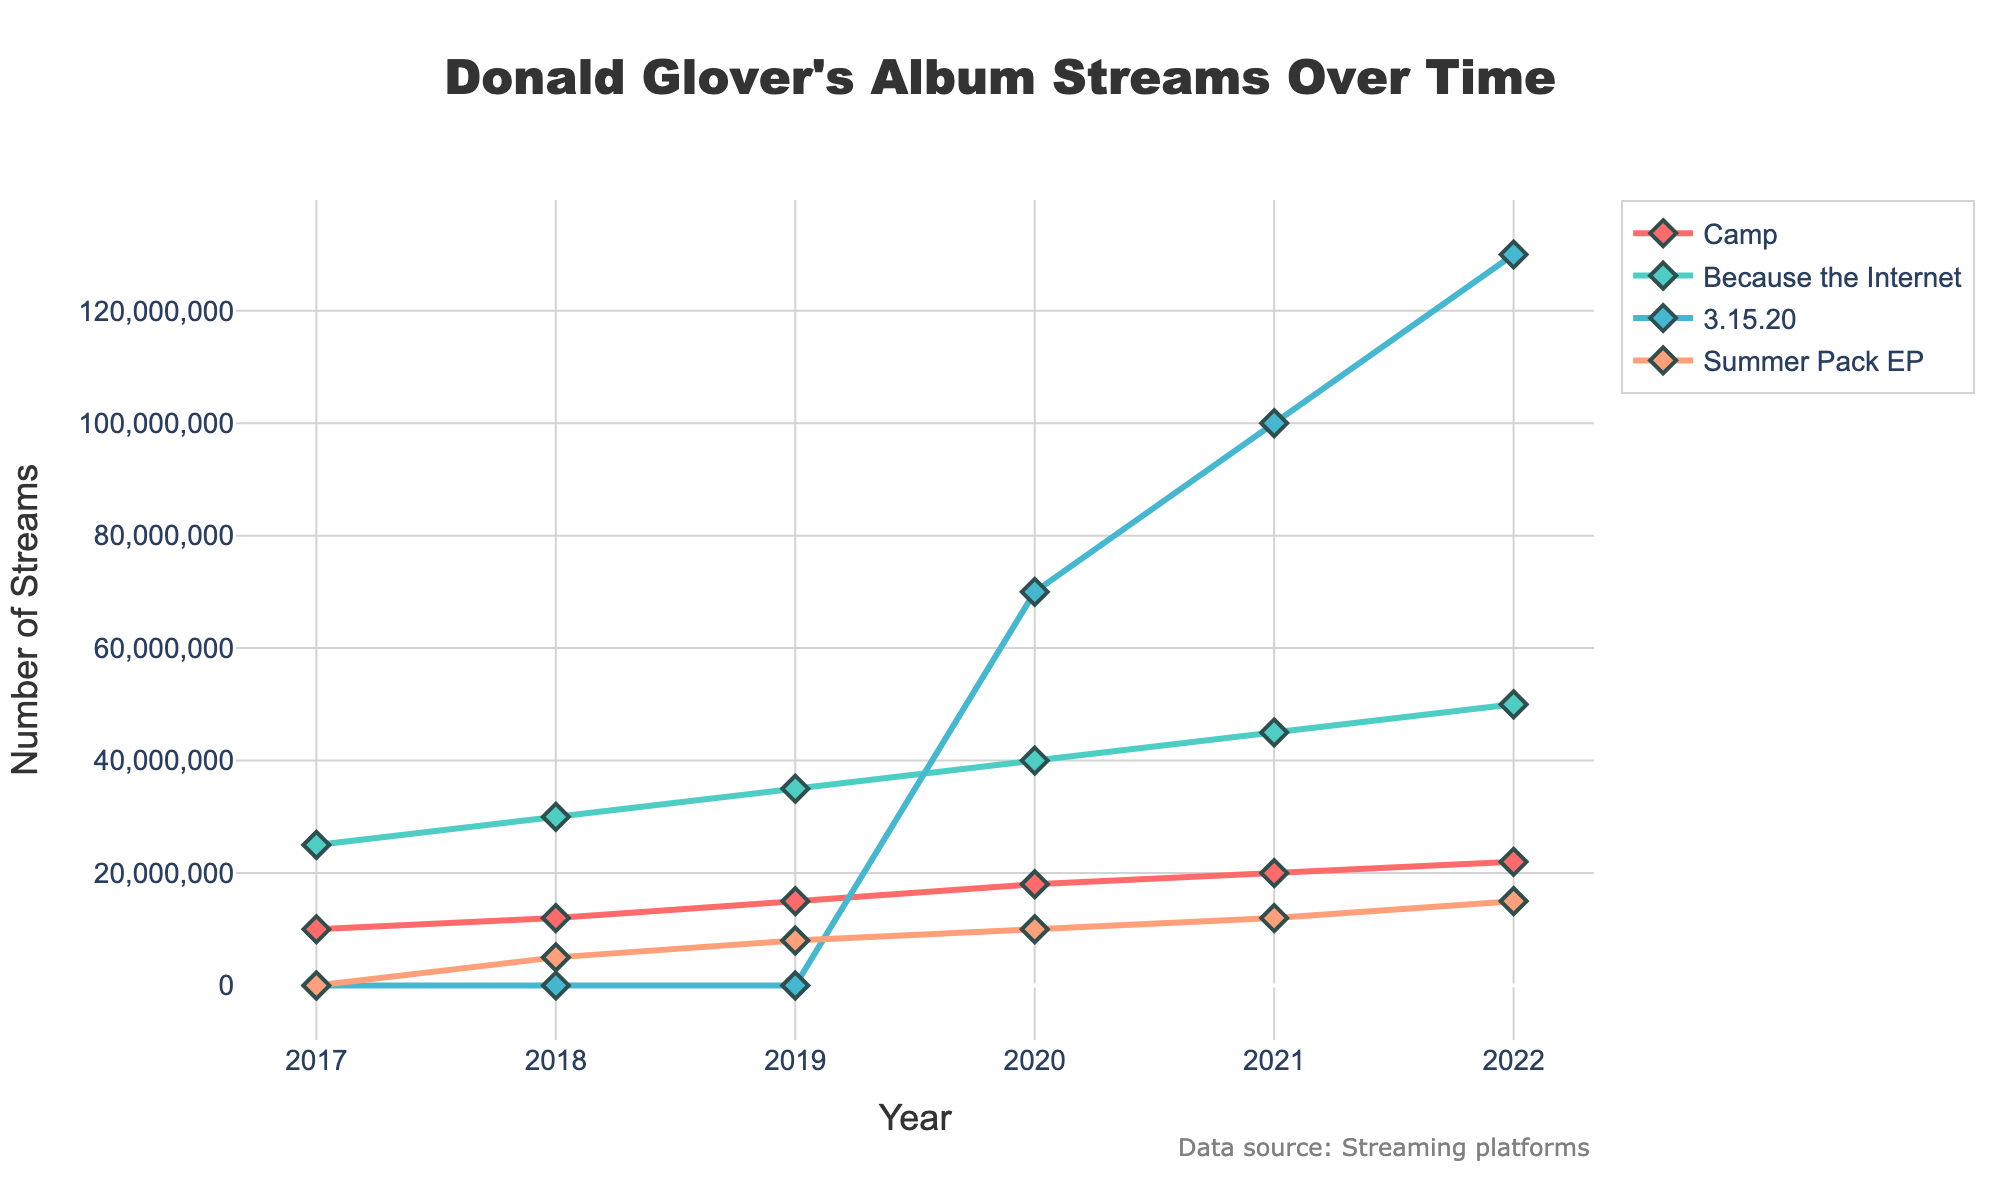What is the total number of streams for the album "3.15.20" from 2020 to 2022? Add the number of streams for "3.15.20" in 2020, 2021, and 2022: 70,000,000 + 100,000,000 + 130,000,000 = 300,000,000
Answer: 300,000,000 In 2020, which album had more streams: "Camp" or "Summer Pack EP"? Compare the number of streams for "Camp" and "Summer Pack EP" in 2020: "Camp" had 18,000,000 streams and "Summer Pack EP" had 10,000,000 streams. 18,000,000 > 10,000,000
Answer: "Camp" Which album showed the most significant increase in streams between 2019 and 2020? Compare the increase in streams for 2019 and 2020 for each album and find the greatest difference: "Camp" increased by 3,000,000, "Because the Internet" increased by 5,000,000, "3.15.20" was newly released with 70,000,000, and "Summer Pack EP" increased by 2,000,000. The largest increase is 70,000,000 for "3.15.20"
Answer: "3.15.20" Which album had the least streams in 2022? Compare the number of streams for each album in 2022: "Camp" had 22,000,000, "Because the Internet" had 50,000,000, "3.15.20" had 130,000,000, and "Summer Pack EP" had 15,000,000. The least is 15,000,000 by "Summer Pack EP"
Answer: "Summer Pack EP" By how much did the number of streams for "Because the Internet" increase from 2017 to 2022? Subtract the number of streams for "Because the Internet" in 2017 from the streams in 2022: 50,000,000 - 25,000,000 = 25,000,000
Answer: 25,000,000 What is the average number of streams for the album "Camp" from 2017 to 2022? Calculate the average by summing the streams for "Camp" over the years and dividing by the number of years: (10,000,000 + 12,000,000 + 15,000,000 + 18,000,000 + 20,000,000 + 22,000,000) / 6 = 16,166,666.67
Answer: 16,166,666.67 Which album experienced consistent growth in streams every year from 2017 to 2022? Check the yearly stream data for each album to see if there is an increase every year: "Camp" grew from 10,000,000 to 22,000,000, "Because the Internet" grew from 25,000,000 to 50,000,000, "3.15.20" started streaming in 2020, and "Summer Pack EP" grew from 0 to 15,000,000. Both "Camp" and "Because the Internet" experienced consistent growth
Answer: "Camp", "Because the Internet" 